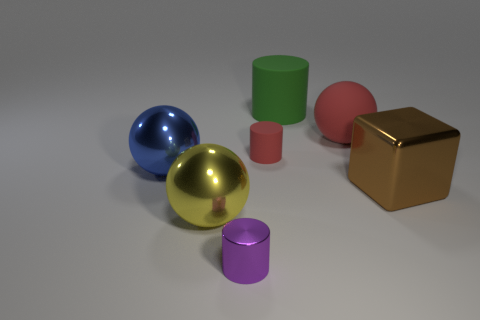Add 1 tiny red things. How many objects exist? 8 Subtract all balls. How many objects are left? 4 Subtract all green cylinders. Subtract all brown shiny blocks. How many objects are left? 5 Add 4 small matte things. How many small matte things are left? 5 Add 6 green rubber spheres. How many green rubber spheres exist? 6 Subtract 0 cyan cylinders. How many objects are left? 7 